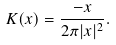Convert formula to latex. <formula><loc_0><loc_0><loc_500><loc_500>K ( x ) = \frac { - x } { 2 \pi | x | ^ { 2 } } .</formula> 